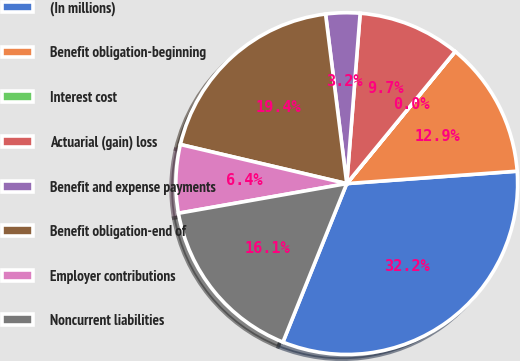Convert chart to OTSL. <chart><loc_0><loc_0><loc_500><loc_500><pie_chart><fcel>(In millions)<fcel>Benefit obligation-beginning<fcel>Interest cost<fcel>Actuarial (gain) loss<fcel>Benefit and expense payments<fcel>Benefit obligation-end of<fcel>Employer contributions<fcel>Noncurrent liabilities<nl><fcel>32.25%<fcel>12.9%<fcel>0.01%<fcel>9.68%<fcel>3.23%<fcel>19.35%<fcel>6.45%<fcel>16.13%<nl></chart> 